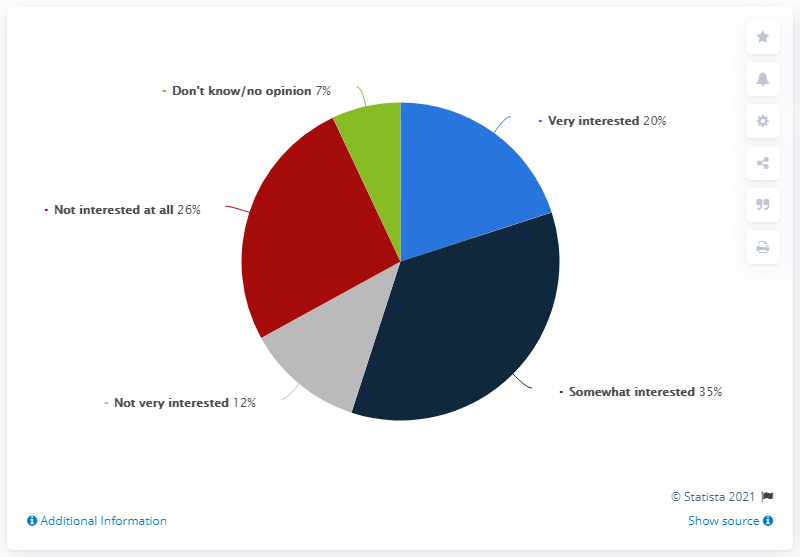Point out several critical features in this image. According to a survey in the United States, 20% of respondents indicated a strong interest in men's Olympic sports. It is estimated that approximately 20 people are highly interested in this topic. The ratio of very interested to somewhat interested is 0.57142857143. 